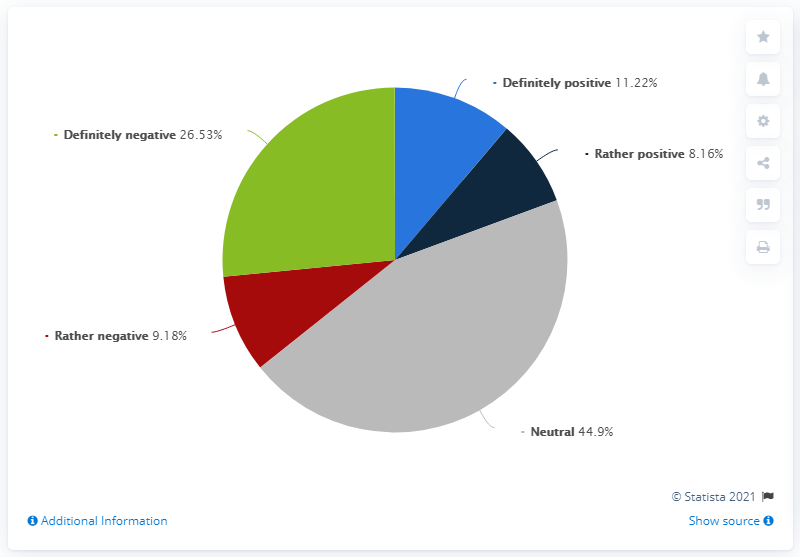Identify some key points in this picture. The sum of the four smaller segments is 55.09. The neutral opinion, minus the average of all opinions, results in a value of 24.9. 